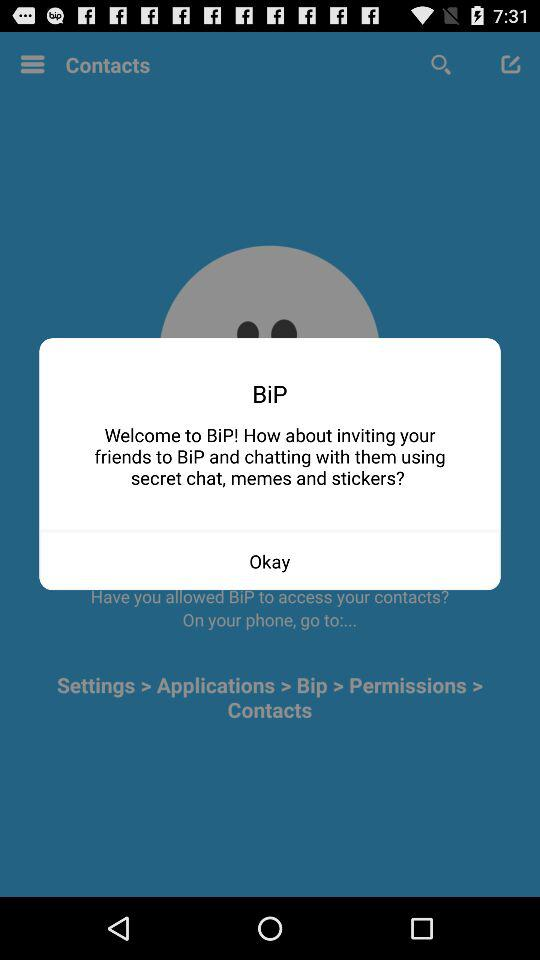What is the application name? The name of the application is "BiP". 